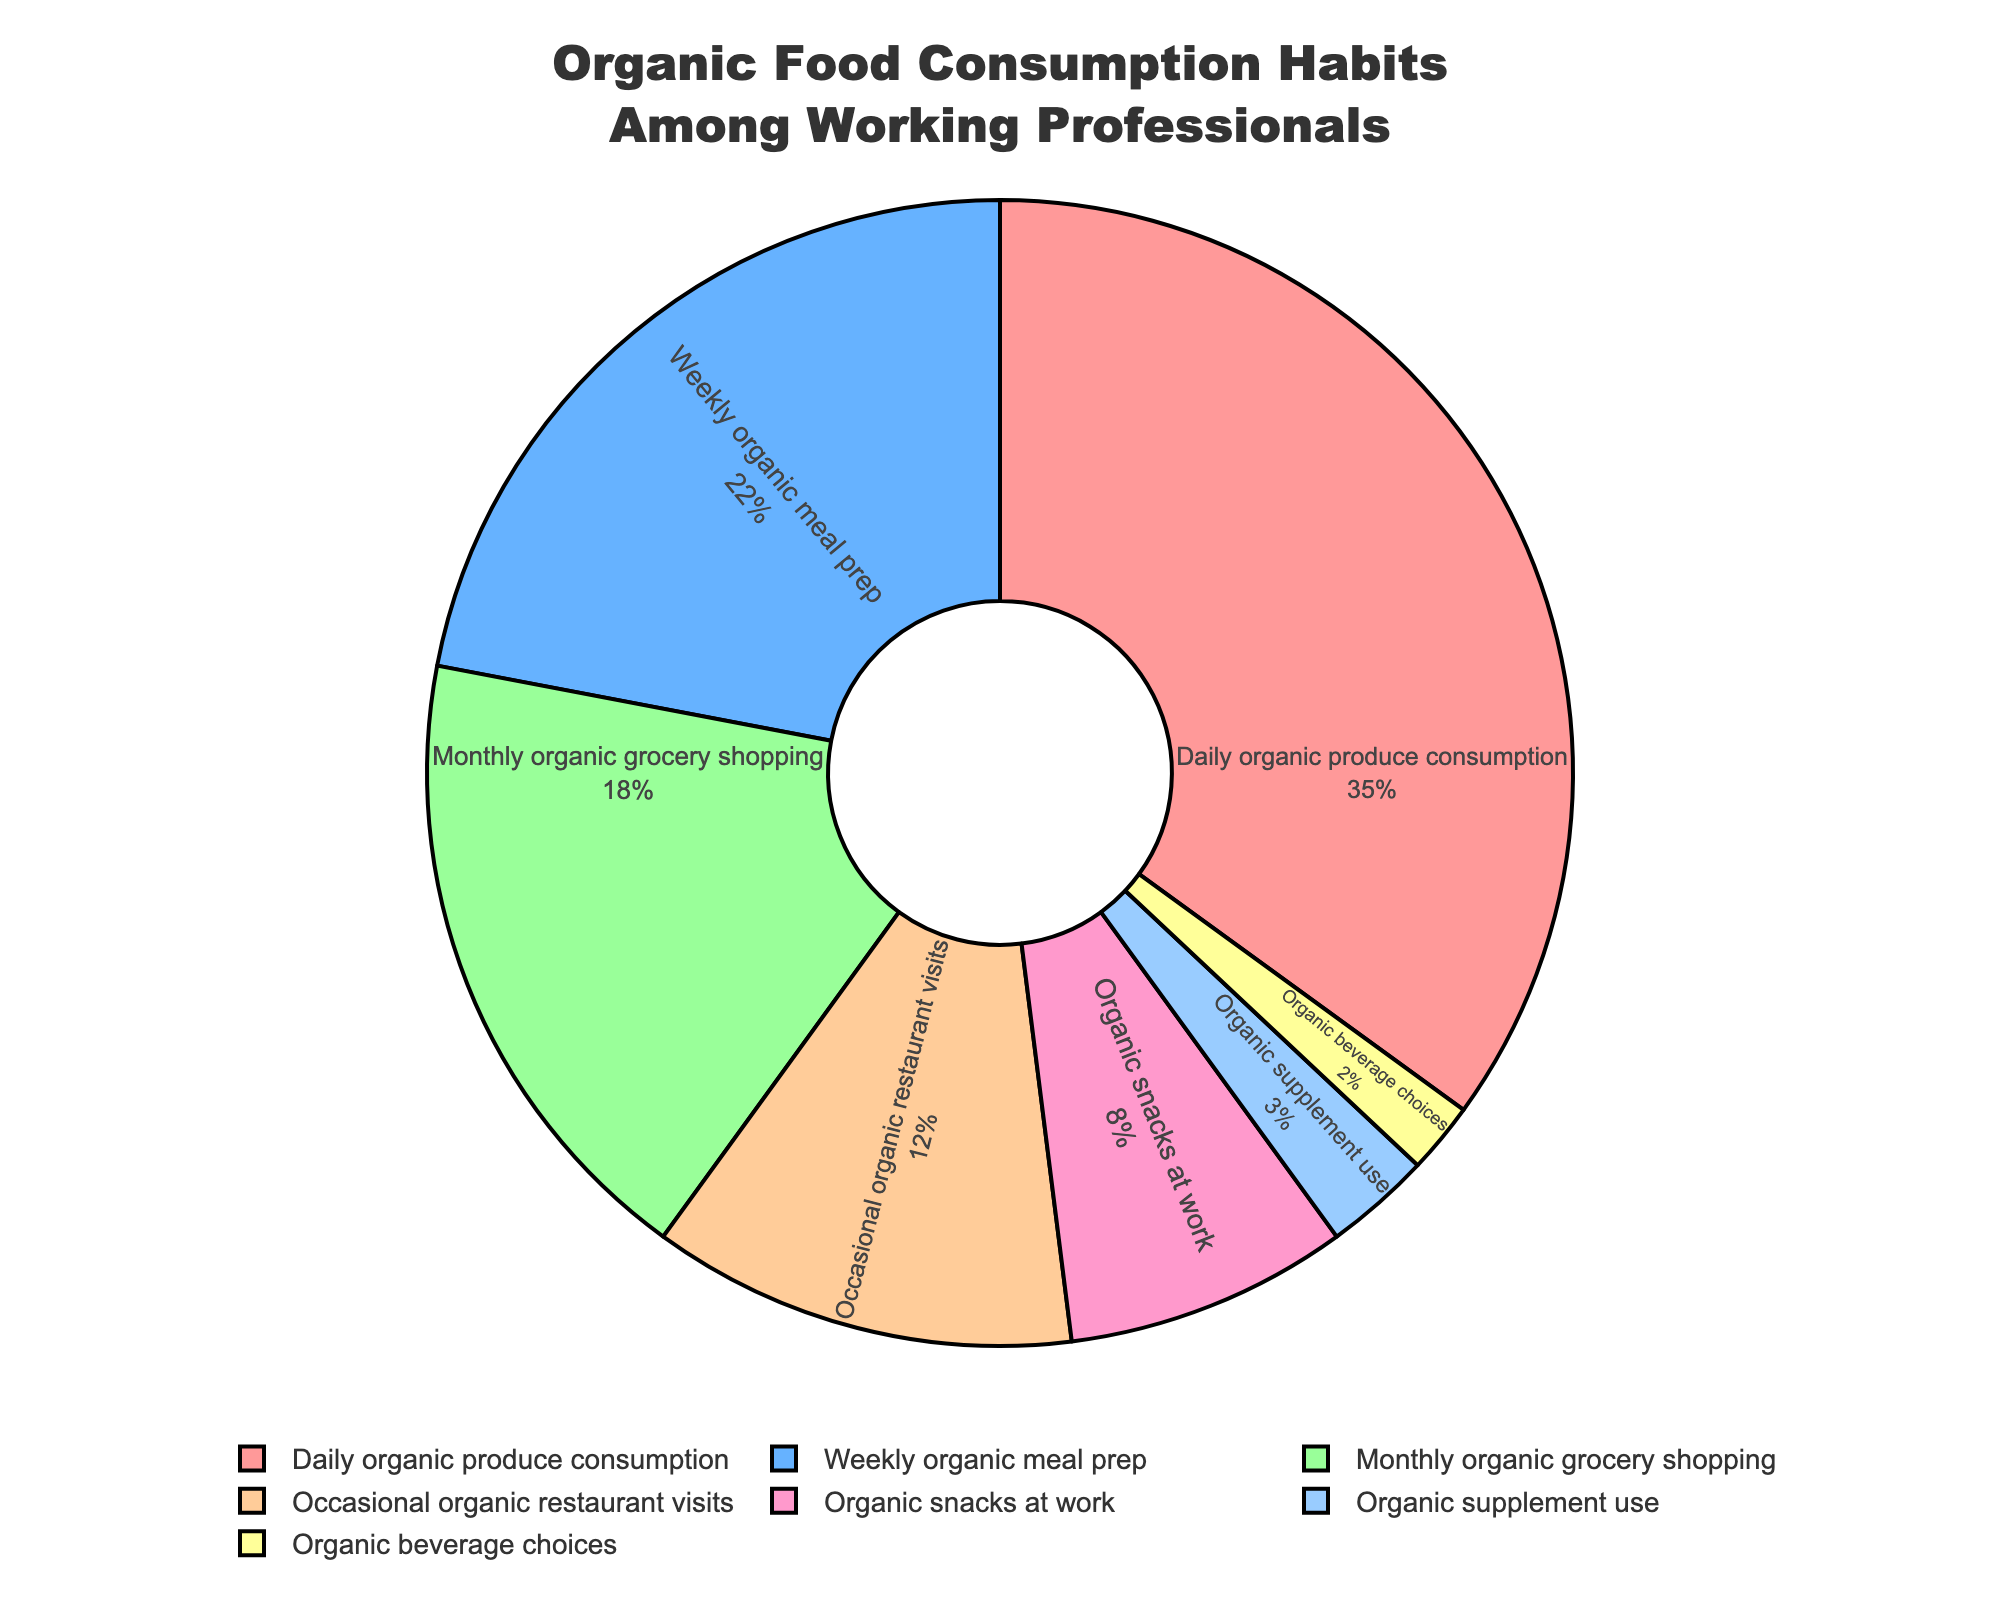Which category has the highest percentage of organic food consumption? The figure shows different categories of organic food consumption habits, with each slice labeled with a percentage. The category with the largest slice, labeled 35%, is "Daily organic produce consumption."
Answer: Daily organic produce consumption What is the total percentage of categories related to weekly and monthly organic habits? Add the percentage for "Weekly organic meal prep" (22%) and "Monthly organic grocery shopping" (18%). 22 + 18 = 40%
Answer: 40% Which category has exactly half the percentage of "Daily organic produce consumption"? Half of 35% (Daily organic produce consumption) is 17.5%. The category with the closest percentage to 17.5% is "Monthly organic grocery shopping," which has 18%.
Answer: Monthly organic grocery shopping What is the difference in percentage between "Occasional organic restaurant visits" and "Organic snacks at work"? The figure shows "Occasional organic restaurant visits" at 12% and "Organic snacks at work" at 8%. Subtract 8 from 12 to find the difference. 12 - 8 = 4%
Answer: 4% Are there more working professionals who consume organic beverages or use organic supplements? The figure shows "Organic supplement use" at 3% and "Organic beverage choices" at 2%. Since 3% is greater than 2%, more professionals use organic supplements.
Answer: Organic supplement use Which category represents the smallest proportion of organic food consumption habits? The smallest slice in the figure, labeled 2%, corresponds to "Organic beverage choices."
Answer: Organic beverage choices If all categories related to food (excluding supplements and beverages) are combined, what is their total percentage? Add the percentages of "Daily organic produce consumption" (35%), "Weekly organic meal prep" (22%), "Monthly organic grocery shopping" (18%), "Occasional organic restaurant visits" (12%), and "Organic snacks at work" (8%). 35 + 22 + 18 + 12 + 8 = 95%
Answer: 95% What color is used to represent "Weekly organic meal prep"? The specific section of the pie chart labeled "Weekly organic meal prep" is colored blue.
Answer: Blue 